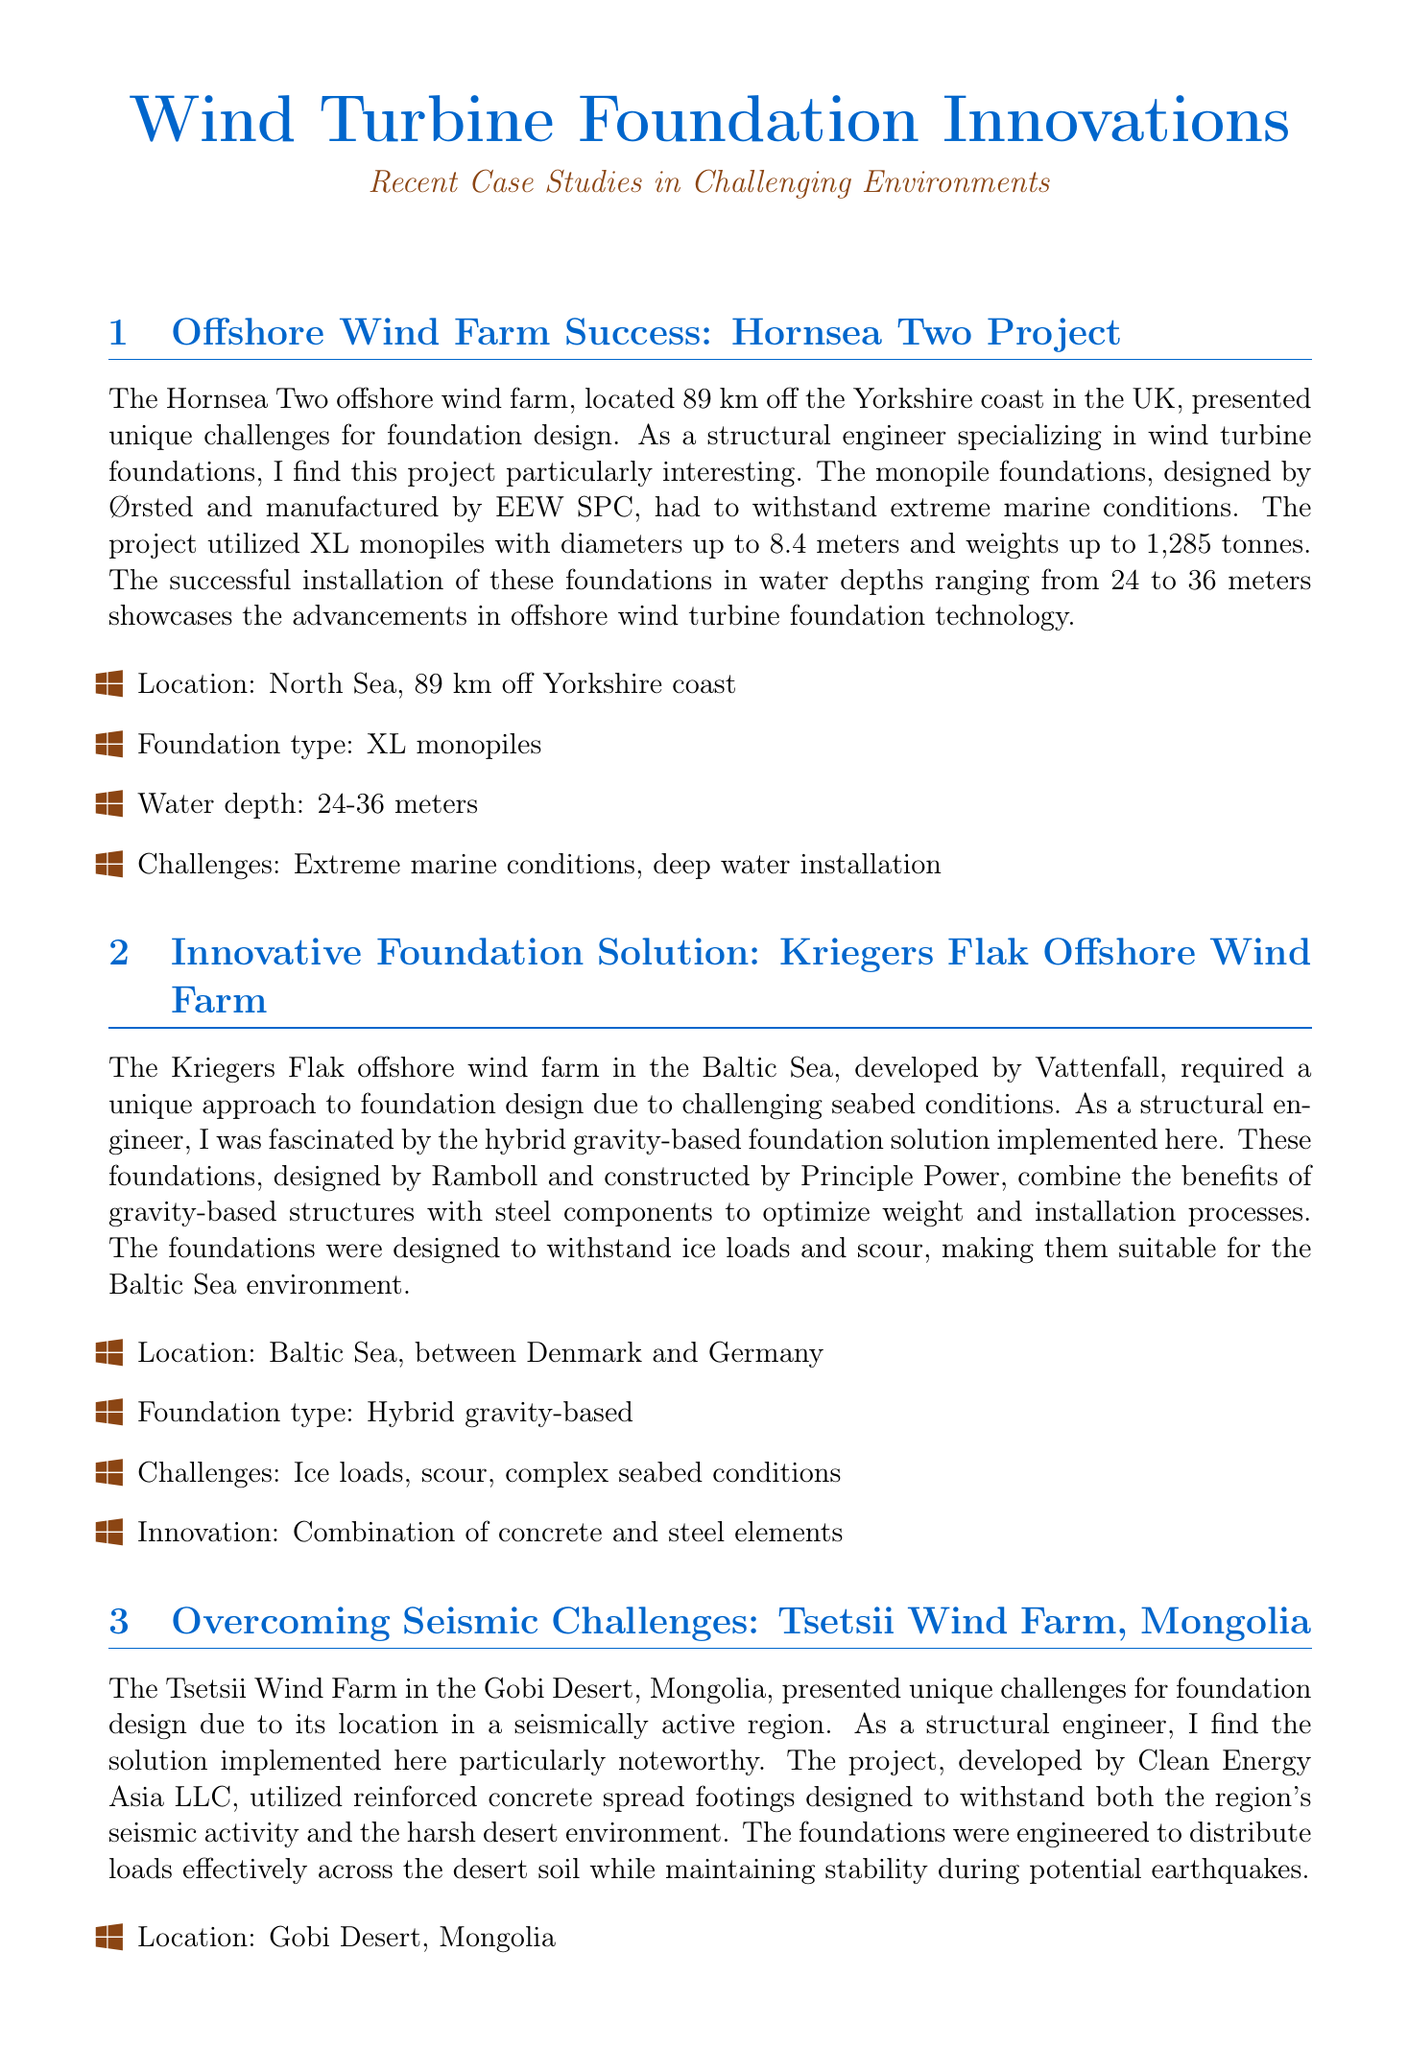What is the location of the Hornsea Two project? The Hornsea Two offshore wind farm is located in the North Sea, 89 km off the Yorkshire coast, as stated in the document.
Answer: North Sea, 89 km off Yorkshire coast What type of foundation was used for the Kriegers Flak offshore wind farm? The document mentions that the Kriegers Flak project used a hybrid gravity-based foundation solution.
Answer: Hybrid gravity-based What is the maximum water depth for the WindFloat Atlantic project? The document states that the WindFloat Atlantic project allows installations in water depths exceeding 100 meters.
Answer: Over 100 meters Which project faced challenges due to seismic activity? The Tsetsii Wind Farm in Mongolia is noted for having challenges related to seismic activity in the document.
Answer: Tsetsii Wind Farm What innovative foundation type is utilized in the Raglan Mine Wind Farm? The document describes the use of adfreeze piles that extend deep into the permafrost for the Raglan Mine Wind Farm.
Answer: Adfreeze piles What combination of materials does the Kriegers Flak foundation solution use? The document highlights that the foundation combines concrete and steel elements.
Answer: Combination of concrete and steel elements What special consideration was important for the Tsetsii Wind Farm foundations? The foundations were engineered to ensure load distribution and seismic stability according to the document.
Answer: Load distribution and seismic stability What innovation does the WindFloat Atlantic project represent? The document notes that the project enables deep-water wind farm installations through the use of semi-submersible floating platforms.
Answer: Enabling deep-water wind farm installations What type of engineering challenges were addressed at the Raglan Mine Wind Farm? The document states that challenges included permafrost and extreme cold conditions.
Answer: Permafrost, extreme cold 